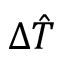<formula> <loc_0><loc_0><loc_500><loc_500>\Delta \hat { T }</formula> 